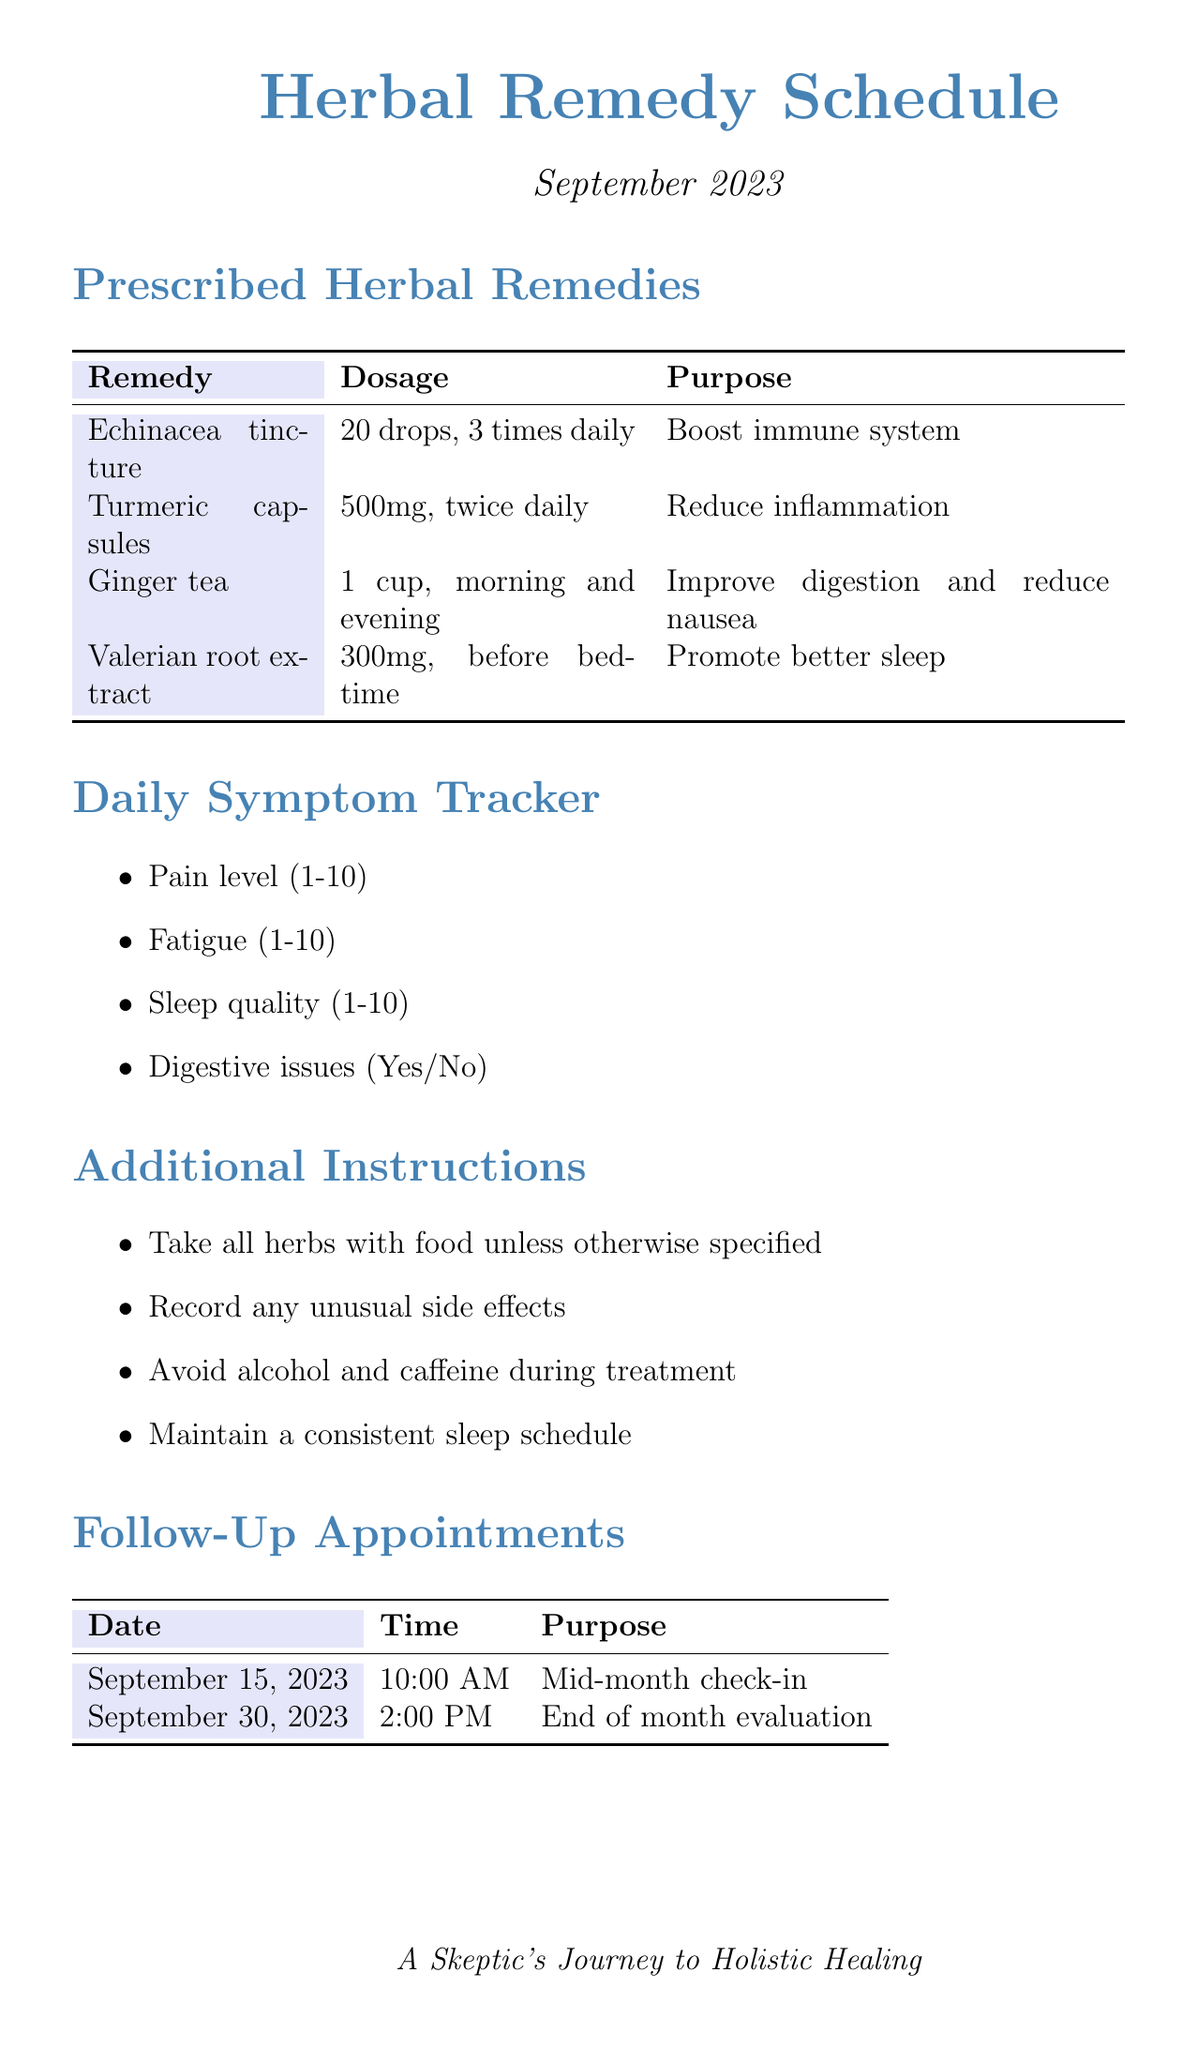What is the purpose of Echinacea tincture? The purpose of Echinacea tincture is stated in the document as "Boost immune system."
Answer: Boost immune system How many drops of Echinacea tincture should be taken daily? The document specifies the dosage of Echinacea tincture as "20 drops, 3 times daily."
Answer: 20 drops, 3 times daily What is the date of the mid-month check-in? The date for the mid-month check-in is noted in the document as "September 15, 2023."
Answer: September 15, 2023 How many herbal remedies are listed in the document? The document lists a total of four herbal remedies, which can be counted in the Prescribed Herbal Remedies section.
Answer: 4 What is the contact email for the emergency contact? The email for the emergency contact, Dr. Amelia Chen, is provided in the document as "dr.chen@holistichealing.com."
Answer: dr.chen@holistichealing.com What should be recorded according to the additional instructions? The additional instructions state that any "unusual side effects" should be recorded.
Answer: Unusual side effects What is the total number of weeks for progress notes? The document contains progress notes for four weeks, as indicated in the Weekly Progress Notes section.
Answer: 4 What should be avoided during treatment? The additional instructions mention avoiding "alcohol and caffeine during treatment."
Answer: Alcohol and caffeine What time is the end of month evaluation scheduled? The time for the end of month evaluation is listed as "2:00 PM" in the Follow-Up Appointments section.
Answer: 2:00 PM 